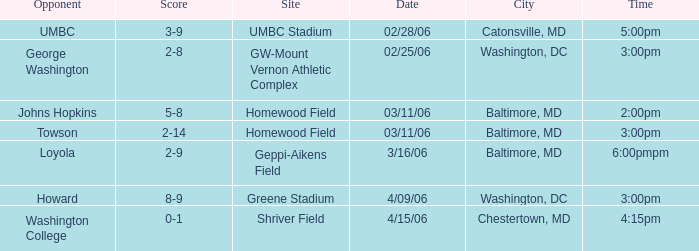Which Score has a Time of 5:00pm? 3-9. Can you parse all the data within this table? {'header': ['Opponent', 'Score', 'Site', 'Date', 'City', 'Time'], 'rows': [['UMBC', '3-9', 'UMBC Stadium', '02/28/06', 'Catonsville, MD', '5:00pm'], ['George Washington', '2-8', 'GW-Mount Vernon Athletic Complex', '02/25/06', 'Washington, DC', '3:00pm'], ['Johns Hopkins', '5-8', 'Homewood Field', '03/11/06', 'Baltimore, MD', '2:00pm'], ['Towson', '2-14', 'Homewood Field', '03/11/06', 'Baltimore, MD', '3:00pm'], ['Loyola', '2-9', 'Geppi-Aikens Field', '3/16/06', 'Baltimore, MD', '6:00pmpm'], ['Howard', '8-9', 'Greene Stadium', '4/09/06', 'Washington, DC', '3:00pm'], ['Washington College', '0-1', 'Shriver Field', '4/15/06', 'Chestertown, MD', '4:15pm']]} 